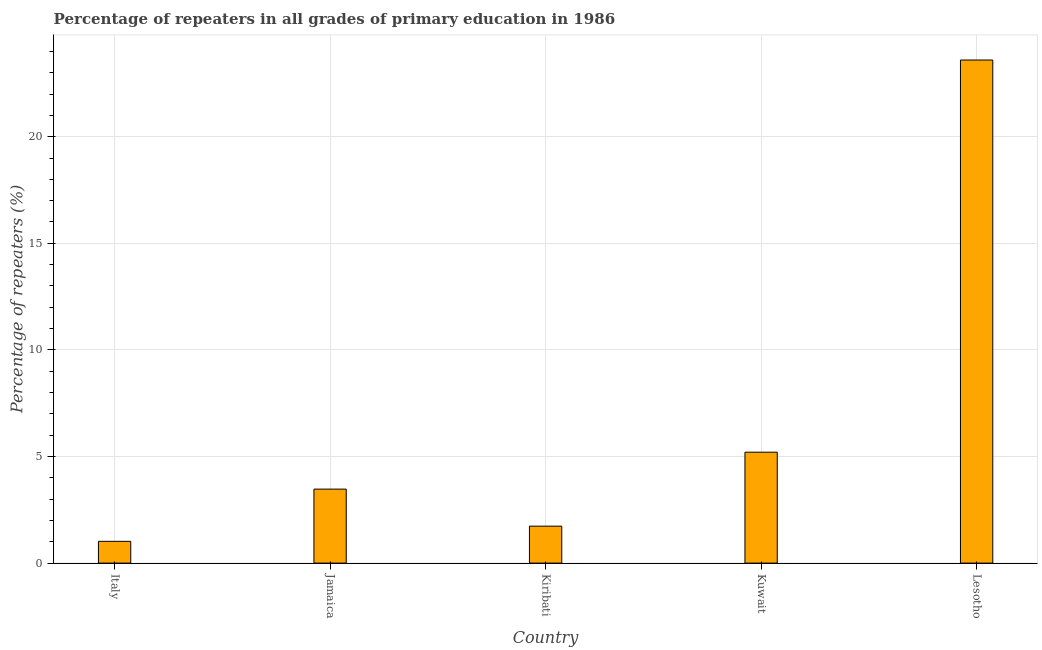Does the graph contain any zero values?
Your answer should be compact. No. What is the title of the graph?
Your answer should be compact. Percentage of repeaters in all grades of primary education in 1986. What is the label or title of the Y-axis?
Offer a terse response. Percentage of repeaters (%). What is the percentage of repeaters in primary education in Lesotho?
Keep it short and to the point. 23.6. Across all countries, what is the maximum percentage of repeaters in primary education?
Provide a succinct answer. 23.6. Across all countries, what is the minimum percentage of repeaters in primary education?
Offer a terse response. 1.02. In which country was the percentage of repeaters in primary education maximum?
Your answer should be very brief. Lesotho. What is the sum of the percentage of repeaters in primary education?
Give a very brief answer. 35.02. What is the difference between the percentage of repeaters in primary education in Kuwait and Lesotho?
Offer a terse response. -18.39. What is the average percentage of repeaters in primary education per country?
Your answer should be compact. 7. What is the median percentage of repeaters in primary education?
Offer a very short reply. 3.47. What is the ratio of the percentage of repeaters in primary education in Italy to that in Jamaica?
Your response must be concise. 0.29. Is the percentage of repeaters in primary education in Kiribati less than that in Kuwait?
Provide a short and direct response. Yes. What is the difference between the highest and the second highest percentage of repeaters in primary education?
Your response must be concise. 18.39. What is the difference between the highest and the lowest percentage of repeaters in primary education?
Give a very brief answer. 22.58. In how many countries, is the percentage of repeaters in primary education greater than the average percentage of repeaters in primary education taken over all countries?
Make the answer very short. 1. Are all the bars in the graph horizontal?
Offer a terse response. No. How many countries are there in the graph?
Your answer should be compact. 5. What is the Percentage of repeaters (%) of Italy?
Ensure brevity in your answer.  1.02. What is the Percentage of repeaters (%) of Jamaica?
Offer a terse response. 3.47. What is the Percentage of repeaters (%) in Kiribati?
Offer a very short reply. 1.73. What is the Percentage of repeaters (%) of Kuwait?
Your answer should be compact. 5.2. What is the Percentage of repeaters (%) in Lesotho?
Your answer should be compact. 23.6. What is the difference between the Percentage of repeaters (%) in Italy and Jamaica?
Your answer should be compact. -2.45. What is the difference between the Percentage of repeaters (%) in Italy and Kiribati?
Offer a terse response. -0.71. What is the difference between the Percentage of repeaters (%) in Italy and Kuwait?
Offer a terse response. -4.18. What is the difference between the Percentage of repeaters (%) in Italy and Lesotho?
Provide a short and direct response. -22.58. What is the difference between the Percentage of repeaters (%) in Jamaica and Kiribati?
Your answer should be very brief. 1.74. What is the difference between the Percentage of repeaters (%) in Jamaica and Kuwait?
Your answer should be very brief. -1.73. What is the difference between the Percentage of repeaters (%) in Jamaica and Lesotho?
Give a very brief answer. -20.13. What is the difference between the Percentage of repeaters (%) in Kiribati and Kuwait?
Give a very brief answer. -3.47. What is the difference between the Percentage of repeaters (%) in Kiribati and Lesotho?
Give a very brief answer. -21.86. What is the difference between the Percentage of repeaters (%) in Kuwait and Lesotho?
Your answer should be very brief. -18.39. What is the ratio of the Percentage of repeaters (%) in Italy to that in Jamaica?
Your response must be concise. 0.29. What is the ratio of the Percentage of repeaters (%) in Italy to that in Kiribati?
Your response must be concise. 0.59. What is the ratio of the Percentage of repeaters (%) in Italy to that in Kuwait?
Provide a short and direct response. 0.2. What is the ratio of the Percentage of repeaters (%) in Italy to that in Lesotho?
Your answer should be compact. 0.04. What is the ratio of the Percentage of repeaters (%) in Jamaica to that in Kiribati?
Provide a short and direct response. 2. What is the ratio of the Percentage of repeaters (%) in Jamaica to that in Kuwait?
Your answer should be very brief. 0.67. What is the ratio of the Percentage of repeaters (%) in Jamaica to that in Lesotho?
Offer a terse response. 0.15. What is the ratio of the Percentage of repeaters (%) in Kiribati to that in Kuwait?
Provide a succinct answer. 0.33. What is the ratio of the Percentage of repeaters (%) in Kiribati to that in Lesotho?
Provide a short and direct response. 0.07. What is the ratio of the Percentage of repeaters (%) in Kuwait to that in Lesotho?
Your response must be concise. 0.22. 